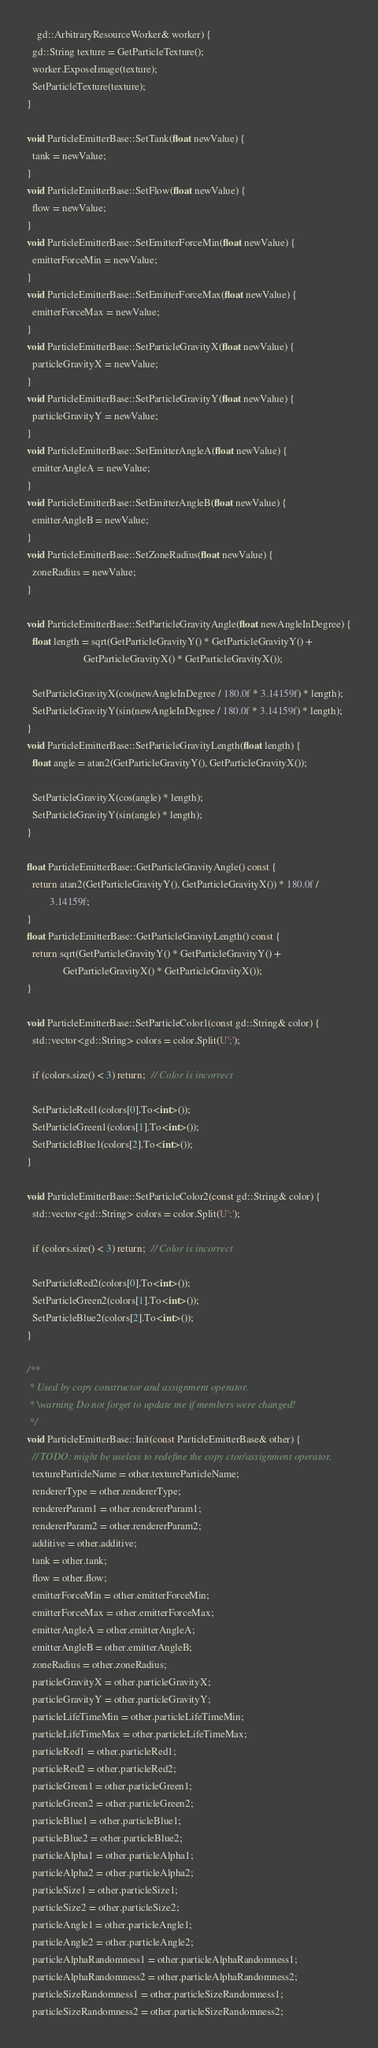<code> <loc_0><loc_0><loc_500><loc_500><_C++_>    gd::ArbitraryResourceWorker& worker) {
  gd::String texture = GetParticleTexture();
  worker.ExposeImage(texture);
  SetParticleTexture(texture);
}

void ParticleEmitterBase::SetTank(float newValue) {
  tank = newValue;
}
void ParticleEmitterBase::SetFlow(float newValue) {
  flow = newValue;
}
void ParticleEmitterBase::SetEmitterForceMin(float newValue) {
  emitterForceMin = newValue;
}
void ParticleEmitterBase::SetEmitterForceMax(float newValue) {
  emitterForceMax = newValue;
}
void ParticleEmitterBase::SetParticleGravityX(float newValue) {
  particleGravityX = newValue;
}
void ParticleEmitterBase::SetParticleGravityY(float newValue) {
  particleGravityY = newValue;
}
void ParticleEmitterBase::SetEmitterAngleA(float newValue) {
  emitterAngleA = newValue;
}
void ParticleEmitterBase::SetEmitterAngleB(float newValue) {
  emitterAngleB = newValue;
}
void ParticleEmitterBase::SetZoneRadius(float newValue) {
  zoneRadius = newValue;
}

void ParticleEmitterBase::SetParticleGravityAngle(float newAngleInDegree) {
  float length = sqrt(GetParticleGravityY() * GetParticleGravityY() +
                      GetParticleGravityX() * GetParticleGravityX());

  SetParticleGravityX(cos(newAngleInDegree / 180.0f * 3.14159f) * length);
  SetParticleGravityY(sin(newAngleInDegree / 180.0f * 3.14159f) * length);
}
void ParticleEmitterBase::SetParticleGravityLength(float length) {
  float angle = atan2(GetParticleGravityY(), GetParticleGravityX());

  SetParticleGravityX(cos(angle) * length);
  SetParticleGravityY(sin(angle) * length);
}

float ParticleEmitterBase::GetParticleGravityAngle() const {
  return atan2(GetParticleGravityY(), GetParticleGravityX()) * 180.0f /
         3.14159f;
}
float ParticleEmitterBase::GetParticleGravityLength() const {
  return sqrt(GetParticleGravityY() * GetParticleGravityY() +
              GetParticleGravityX() * GetParticleGravityX());
}

void ParticleEmitterBase::SetParticleColor1(const gd::String& color) {
  std::vector<gd::String> colors = color.Split(U';');

  if (colors.size() < 3) return;  // Color is incorrect

  SetParticleRed1(colors[0].To<int>());
  SetParticleGreen1(colors[1].To<int>());
  SetParticleBlue1(colors[2].To<int>());
}

void ParticleEmitterBase::SetParticleColor2(const gd::String& color) {
  std::vector<gd::String> colors = color.Split(U';');

  if (colors.size() < 3) return;  // Color is incorrect

  SetParticleRed2(colors[0].To<int>());
  SetParticleGreen2(colors[1].To<int>());
  SetParticleBlue2(colors[2].To<int>());
}

/**
 * Used by copy constructor and assignment operator.
 * \warning Do not forget to update me if members were changed!
 */
void ParticleEmitterBase::Init(const ParticleEmitterBase& other) {
  // TODO: might be useless to redefine the copy ctor/assignment operator.
  textureParticleName = other.textureParticleName;
  rendererType = other.rendererType;
  rendererParam1 = other.rendererParam1;
  rendererParam2 = other.rendererParam2;
  additive = other.additive;
  tank = other.tank;
  flow = other.flow;
  emitterForceMin = other.emitterForceMin;
  emitterForceMax = other.emitterForceMax;
  emitterAngleA = other.emitterAngleA;
  emitterAngleB = other.emitterAngleB;
  zoneRadius = other.zoneRadius;
  particleGravityX = other.particleGravityX;
  particleGravityY = other.particleGravityY;
  particleLifeTimeMin = other.particleLifeTimeMin;
  particleLifeTimeMax = other.particleLifeTimeMax;
  particleRed1 = other.particleRed1;
  particleRed2 = other.particleRed2;
  particleGreen1 = other.particleGreen1;
  particleGreen2 = other.particleGreen2;
  particleBlue1 = other.particleBlue1;
  particleBlue2 = other.particleBlue2;
  particleAlpha1 = other.particleAlpha1;
  particleAlpha2 = other.particleAlpha2;
  particleSize1 = other.particleSize1;
  particleSize2 = other.particleSize2;
  particleAngle1 = other.particleAngle1;
  particleAngle2 = other.particleAngle2;
  particleAlphaRandomness1 = other.particleAlphaRandomness1;
  particleAlphaRandomness2 = other.particleAlphaRandomness2;
  particleSizeRandomness1 = other.particleSizeRandomness1;
  particleSizeRandomness2 = other.particleSizeRandomness2;</code> 